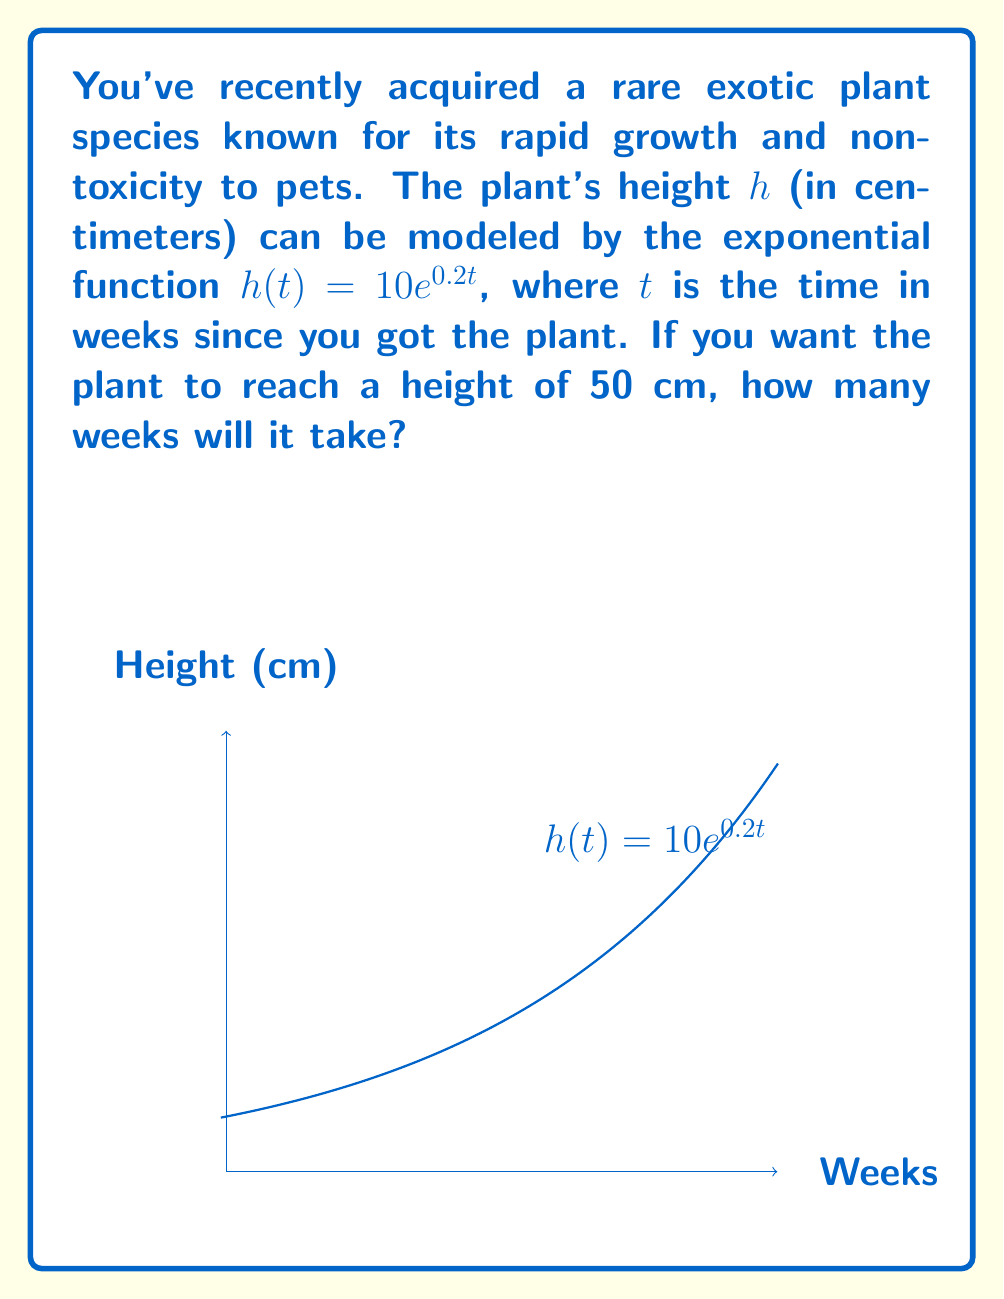Can you answer this question? Let's approach this step-by-step:

1) We're given the exponential growth function: $h(t) = 10e^{0.2t}$

2) We want to find $t$ when $h(t) = 50$ cm. So, we can set up the equation:

   $50 = 10e^{0.2t}$

3) Divide both sides by 10:

   $5 = e^{0.2t}$

4) Take the natural logarithm of both sides:

   $\ln(5) = \ln(e^{0.2t})$

5) The natural log and exponential function cancel on the right side:

   $\ln(5) = 0.2t$

6) Divide both sides by 0.2:

   $\frac{\ln(5)}{0.2} = t$

7) Calculate the value:

   $t \approx 8.047$ weeks

Therefore, it will take approximately 8.05 weeks for the plant to reach a height of 50 cm.
Answer: $\frac{\ln(5)}{0.2} \approx 8.05$ weeks 